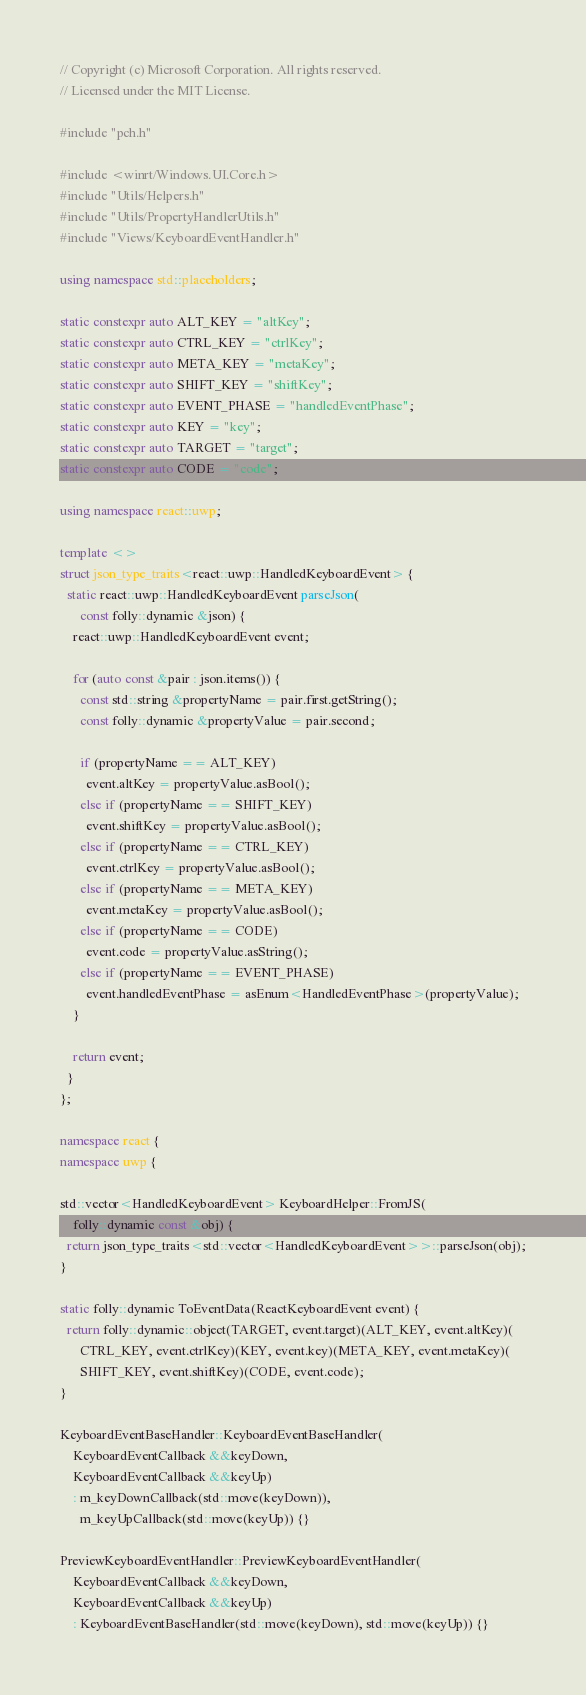Convert code to text. <code><loc_0><loc_0><loc_500><loc_500><_C++_>// Copyright (c) Microsoft Corporation. All rights reserved.
// Licensed under the MIT License.

#include "pch.h"

#include <winrt/Windows.UI.Core.h>
#include "Utils/Helpers.h"
#include "Utils/PropertyHandlerUtils.h"
#include "Views/KeyboardEventHandler.h"

using namespace std::placeholders;

static constexpr auto ALT_KEY = "altKey";
static constexpr auto CTRL_KEY = "ctrlKey";
static constexpr auto META_KEY = "metaKey";
static constexpr auto SHIFT_KEY = "shiftKey";
static constexpr auto EVENT_PHASE = "handledEventPhase";
static constexpr auto KEY = "key";
static constexpr auto TARGET = "target";
static constexpr auto CODE = "code";

using namespace react::uwp;

template <>
struct json_type_traits<react::uwp::HandledKeyboardEvent> {
  static react::uwp::HandledKeyboardEvent parseJson(
      const folly::dynamic &json) {
    react::uwp::HandledKeyboardEvent event;

    for (auto const &pair : json.items()) {
      const std::string &propertyName = pair.first.getString();
      const folly::dynamic &propertyValue = pair.second;

      if (propertyName == ALT_KEY)
        event.altKey = propertyValue.asBool();
      else if (propertyName == SHIFT_KEY)
        event.shiftKey = propertyValue.asBool();
      else if (propertyName == CTRL_KEY)
        event.ctrlKey = propertyValue.asBool();
      else if (propertyName == META_KEY)
        event.metaKey = propertyValue.asBool();
      else if (propertyName == CODE)
        event.code = propertyValue.asString();
      else if (propertyName == EVENT_PHASE)
        event.handledEventPhase = asEnum<HandledEventPhase>(propertyValue);
    }

    return event;
  }
};

namespace react {
namespace uwp {

std::vector<HandledKeyboardEvent> KeyboardHelper::FromJS(
    folly::dynamic const &obj) {
  return json_type_traits<std::vector<HandledKeyboardEvent>>::parseJson(obj);
}

static folly::dynamic ToEventData(ReactKeyboardEvent event) {
  return folly::dynamic::object(TARGET, event.target)(ALT_KEY, event.altKey)(
      CTRL_KEY, event.ctrlKey)(KEY, event.key)(META_KEY, event.metaKey)(
      SHIFT_KEY, event.shiftKey)(CODE, event.code);
}

KeyboardEventBaseHandler::KeyboardEventBaseHandler(
    KeyboardEventCallback &&keyDown,
    KeyboardEventCallback &&keyUp)
    : m_keyDownCallback(std::move(keyDown)),
      m_keyUpCallback(std::move(keyUp)) {}

PreviewKeyboardEventHandler::PreviewKeyboardEventHandler(
    KeyboardEventCallback &&keyDown,
    KeyboardEventCallback &&keyUp)
    : KeyboardEventBaseHandler(std::move(keyDown), std::move(keyUp)) {}
</code> 